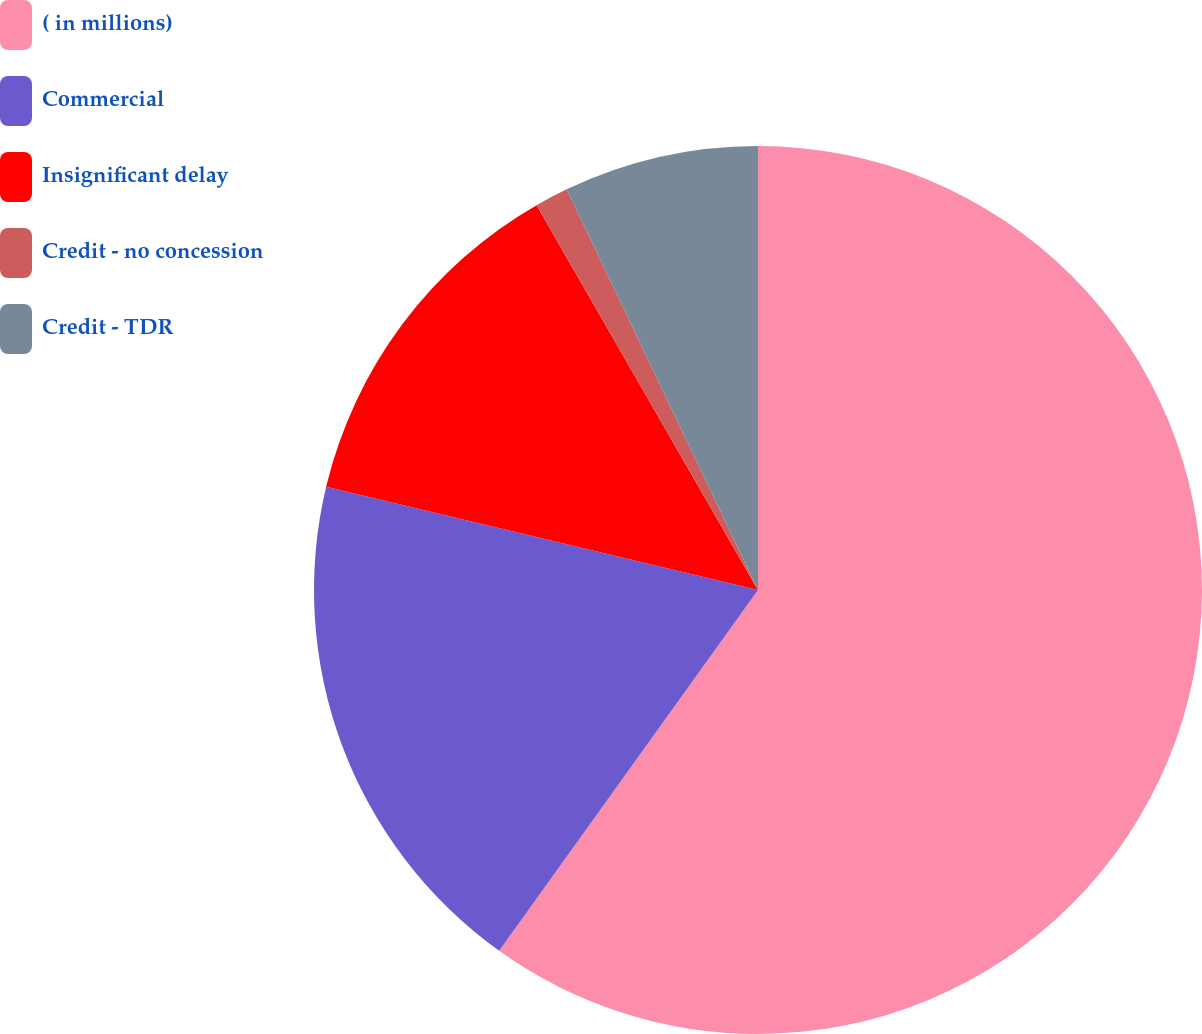Convert chart to OTSL. <chart><loc_0><loc_0><loc_500><loc_500><pie_chart><fcel>( in millions)<fcel>Commercial<fcel>Insignificant delay<fcel>Credit - no concession<fcel>Credit - TDR<nl><fcel>59.91%<fcel>18.83%<fcel>12.96%<fcel>1.22%<fcel>7.09%<nl></chart> 